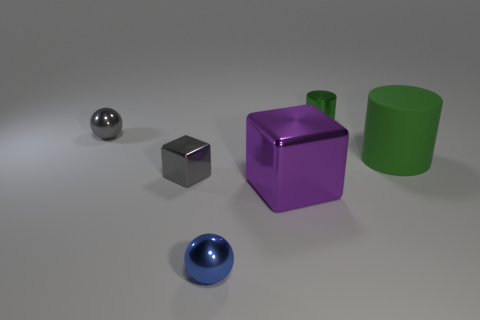There is another cylinder that is the same color as the metallic cylinder; what material is it?
Your answer should be compact. Rubber. Are there any small spheres that have the same color as the small metal block?
Provide a succinct answer. Yes. There is a block to the left of the tiny blue sphere; is there a tiny thing that is right of it?
Provide a succinct answer. Yes. There is a metallic object that is in front of the tiny gray block and behind the blue metal ball; what is its color?
Your response must be concise. Purple. The green rubber object has what size?
Your answer should be very brief. Large. Is the ball that is in front of the tiny gray sphere made of the same material as the sphere behind the large green cylinder?
Give a very brief answer. Yes. What is the cube on the left side of the tiny ball that is right of the gray shiny ball made of?
Offer a terse response. Metal. There is a block that is left of the small blue ball; what material is it?
Offer a terse response. Metal. How many purple metallic objects have the same shape as the small blue thing?
Your answer should be very brief. 0. Do the large matte object and the tiny shiny cylinder have the same color?
Provide a short and direct response. Yes. 